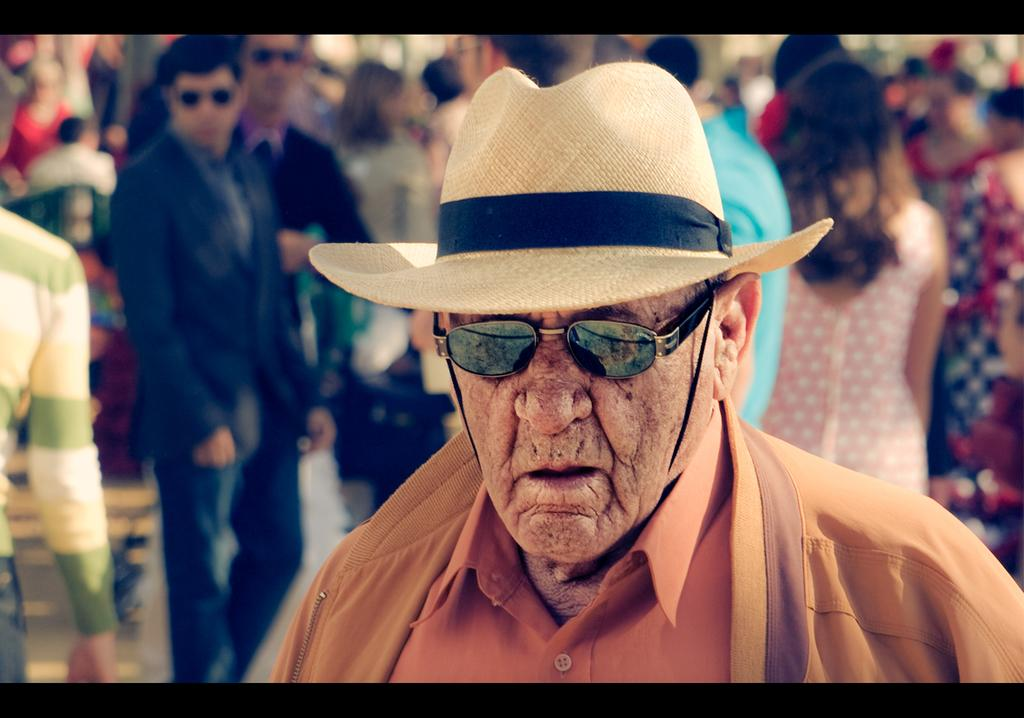Who is the main subject in the image? There is a man in the image. What protective gear is the man wearing? The man is wearing goggles. What type of clothing is the man wearing on his upper body? The man is wearing a shirt and a jacket. What headwear is the man wearing? The man is wearing a hat. Can you describe the setting in the image? There are many people in the background of the image. What type of animal is the man riding in the image? There is no animal present in the image; the man is not riding anything. What color is the shirt the bat is wearing in the image? There is no bat or shirt worn by a bat present in the image. 